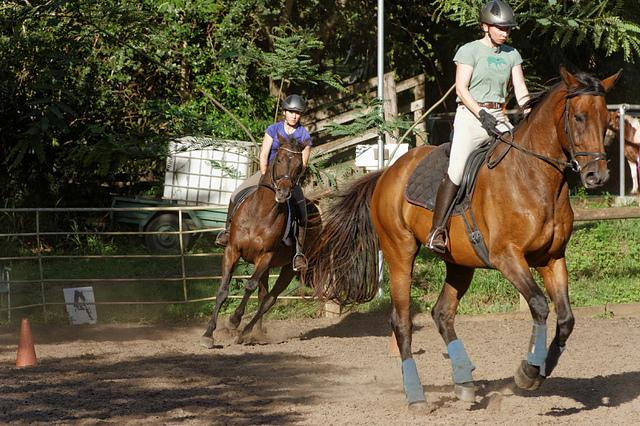Why do the people wear head gear? Please explain your reasoning. protection. This type of sport can be dangerous and you need protection. 